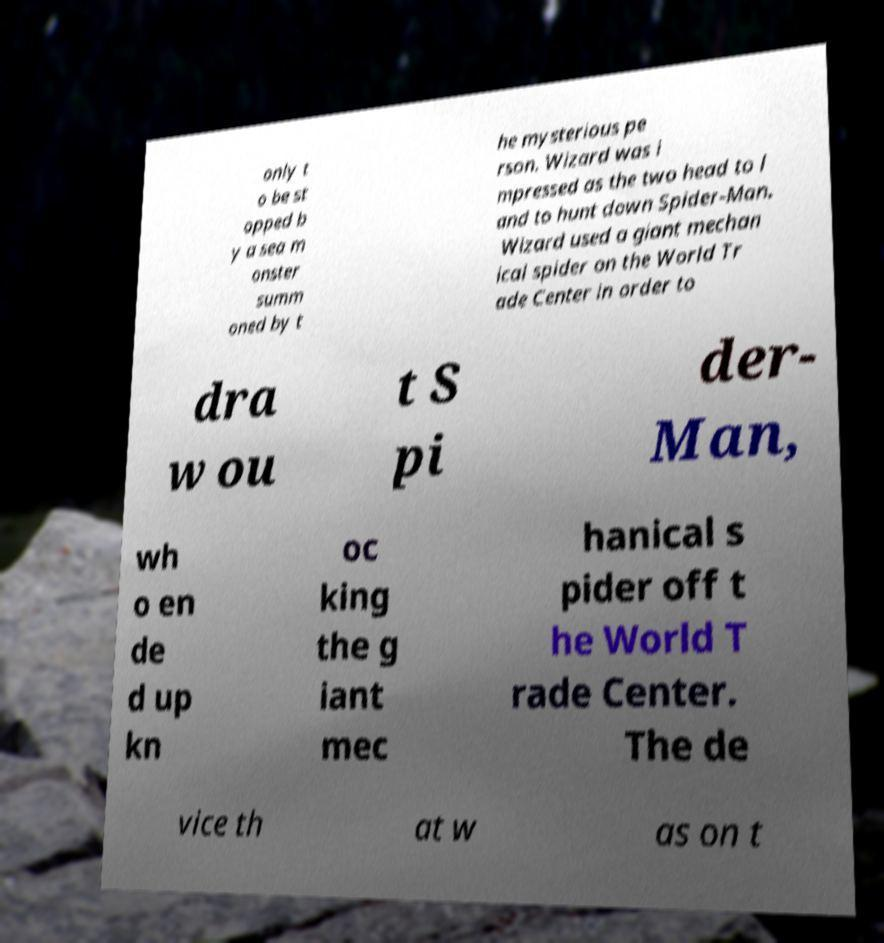Please identify and transcribe the text found in this image. only t o be st opped b y a sea m onster summ oned by t he mysterious pe rson. Wizard was i mpressed as the two head to l and to hunt down Spider-Man. Wizard used a giant mechan ical spider on the World Tr ade Center in order to dra w ou t S pi der- Man, wh o en de d up kn oc king the g iant mec hanical s pider off t he World T rade Center. The de vice th at w as on t 